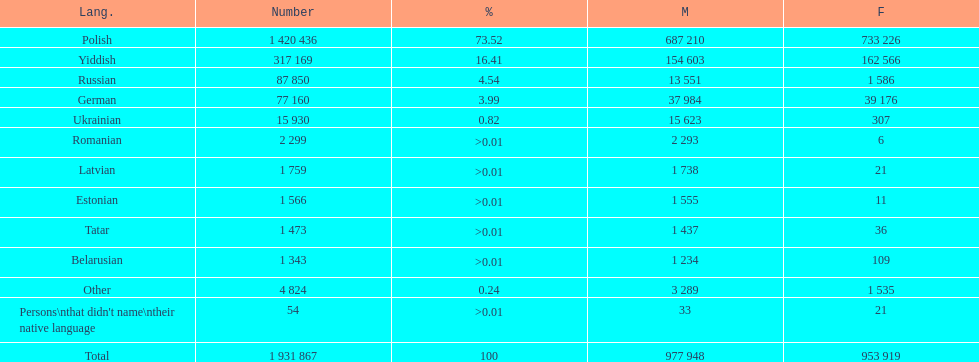Which language had the smallest number of females speaking it. Romanian. 